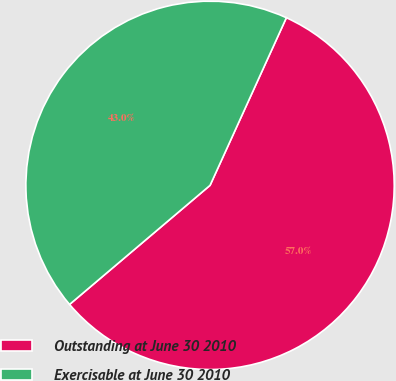Convert chart to OTSL. <chart><loc_0><loc_0><loc_500><loc_500><pie_chart><fcel>Outstanding at June 30 2010<fcel>Exercisable at June 30 2010<nl><fcel>57.01%<fcel>42.99%<nl></chart> 